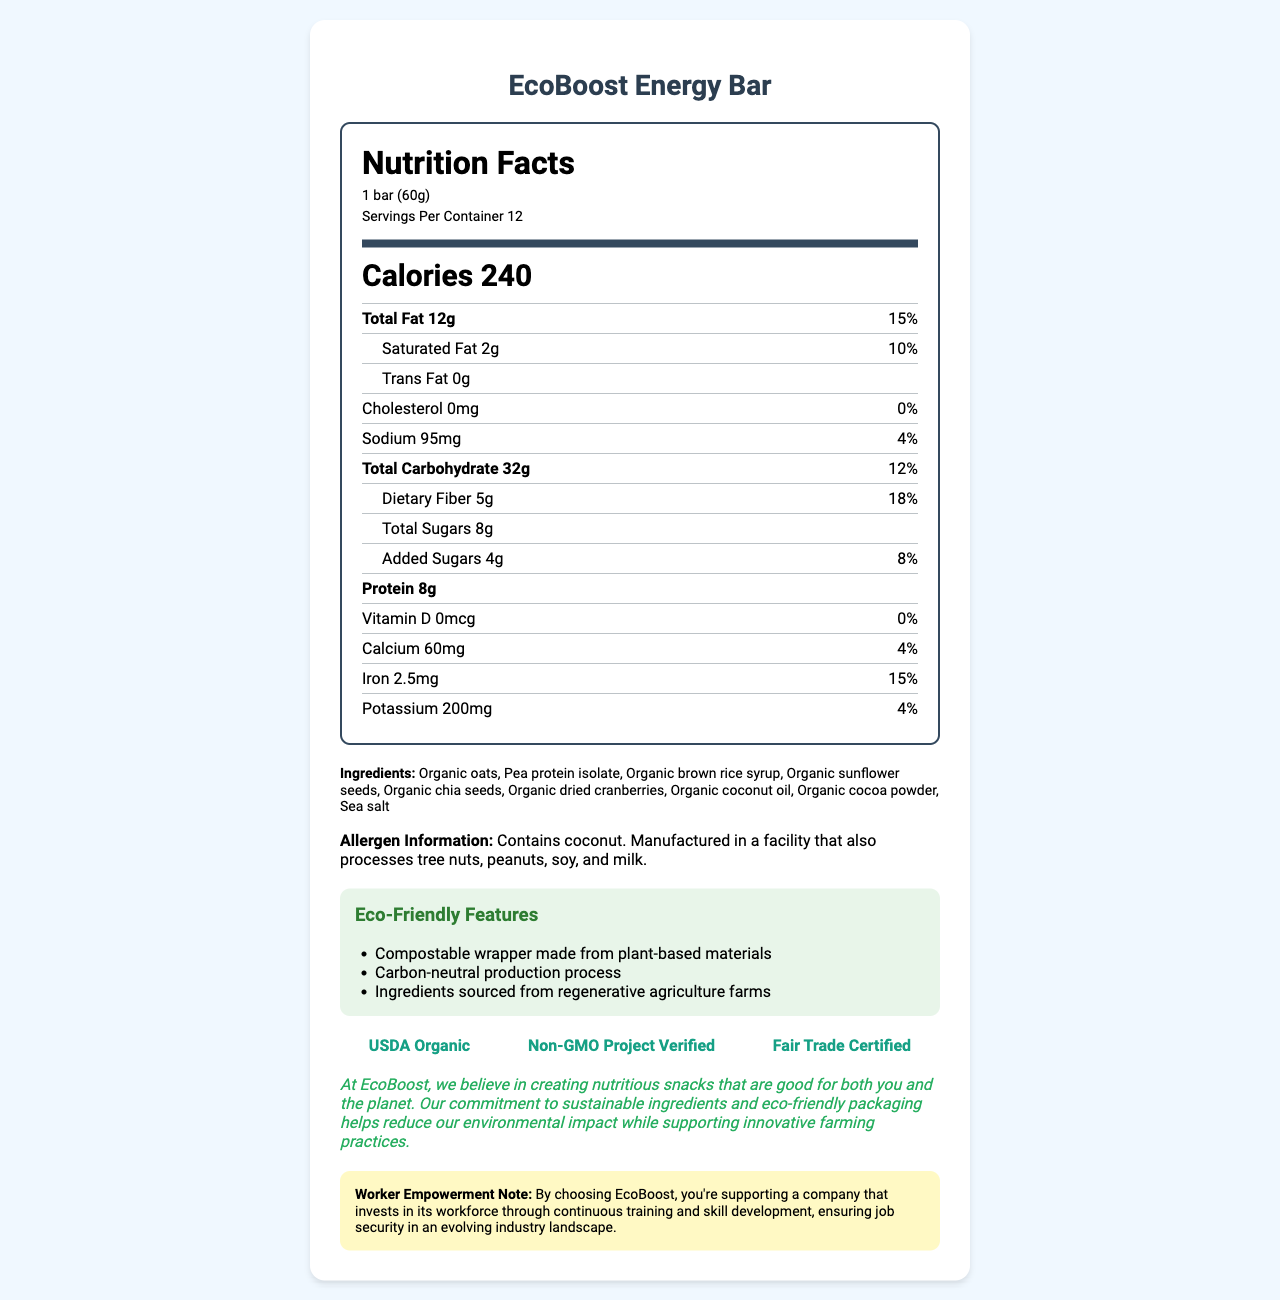what is the serving size? The serving size is listed at the top of the nutrition label as "1 bar (60g)".
Answer: 1 bar (60g) how many calories are in one serving? The calories per serving are listed prominently in the middle of the nutrition label as "Calories 240".
Answer: 240 how much protein is in each bar? The protein content is listed under the nutrient rows as "Protein 8g".
Answer: 8g who is the manufacturer of the energy bar? The manufacturer is not mentioned anywhere in the document.
Answer: Cannot be determined what is the total fat content per serving? The total fat content is listed at the top of the nutrient rows as "Total Fat 12g".
Answer: 12g what percentage of the daily value is the saturated fat content? The daily value percentage for saturated fat is listed next to its amount as "10%".
Answer: 10% what ingredients are used in the energy bar? The ingredients are listed at the bottom of the nutrition label section under "Ingredients".
Answer: Organic oats, Pea protein isolate, Organic brown rice syrup, Organic sunflower seeds, Organic chia seeds, Organic dried cranberries, Organic coconut oil, Organic cocoa powder, Sea salt what nutrients have a daily value percentage of 0%? Both Cholesterol and Vitamin D have a daily value percentage of "0%" as indicated on the nutrient rows.
Answer: Cholesterol, Vitamin D does the bar contain any tree nuts? The allergen information states that it "Contains coconut. Manufactured in a facility that also processes tree nuts, peanuts, soy, and milk."
Answer: Yes what is unique about the wrapper of the EcoBoost Energy Bar? A. It is made of plastic B. It is biodegradable C. It is compostable D. It is reusable The eco-friendly features mention "Compostable wrapper made from plant-based materials".
Answer: C which certification is not listed for the EcoBoost Energy Bar? A. USDA Organic B. Gluten-Free C. Non-GMO Project Verified D. Fair Trade Certified The certifications mentioned are "USDA Organic", "Non-GMO Project Verified", and "Fair Trade Certified". Gluten-Free is not listed.
Answer: B is the EcoBoost Energy Bar free from trans fat? The trans fat content is listed as "0g", indicating that it is free from trans fat.
Answer: Yes summarize the main features of the EcoBoost Energy Bar. The summary highlights the key nutritional information, eco-friendly features, certifications, and worker empowerment initiatives associated with the EcoBoost Energy Bar.
Answer: The EcoBoost Energy Bar is a nutritious snack made with sustainable and organic ingredients. Each bar contains 240 calories, 12g of fat, 8g of protein, and various vitamins and minerals. It has eco-friendly features such as a compostable wrapper and a carbon-neutral production process. The bar is USDA Organic, Non-GMO Project Verified, and Fair Trade Certified, and purchasing it supports worker empowerment through continuous training and skill development. how does EcoBoost support job security for its workers? The worker empowerment note at the bottom of the document mentions that EcoBoost supports job security by "investing in its workforce through continuous training and skill development".
Answer: By investing in continuous training and skill development what is the sodium content per serving? The sodium content is listed under the nutrient rows as "Sodium 95mg".
Answer: 95mg is the production process of the EcoBoost Energy Bar environmentally friendly? The eco-friendly features mention that the bar has a "Carbon-neutral production process".
Answer: Yes how much dietary fiber is in one serving? The dietary fiber content is listed under the nutrient rows as "Dietary Fiber 5g".
Answer: 5g in what type of facility is the energy bar manufactured? The allergen information mentions that the product is "Manufactured in a facility that also processes tree nuts, peanuts, soy, and milk".
Answer: In a facility that also processes tree nuts, peanuts, soy, and milk 